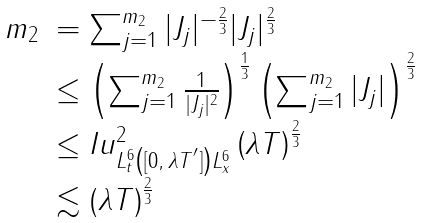<formula> <loc_0><loc_0><loc_500><loc_500>\begin{array} { l l } m _ { 2 } & = \sum _ { j = 1 } ^ { m _ { 2 } } | J _ { j } | ^ { - \frac { 2 } { 3 } } | J _ { j } | ^ { \frac { 2 } { 3 } } \\ & \leq \left ( \sum _ { j = 1 } ^ { m _ { 2 } } \frac { 1 } { | J _ { j } | ^ { 2 } } \right ) ^ { \frac { 1 } { 3 } } \left ( \sum _ { j = 1 } ^ { m _ { 2 } } | J _ { j } | \right ) ^ { \frac { 2 } { 3 } } \\ & \leq \| I u \| ^ { 2 } _ { L _ { t } ^ { 6 } \left ( [ 0 , \, \lambda T ^ { ^ { \prime } } ] \right ) L _ { x } ^ { 6 } } \left ( \lambda T \right ) ^ { \frac { 2 } { 3 } } \\ & \lesssim \left ( \lambda T \right ) ^ { \frac { 2 } { 3 } } \end{array}</formula> 